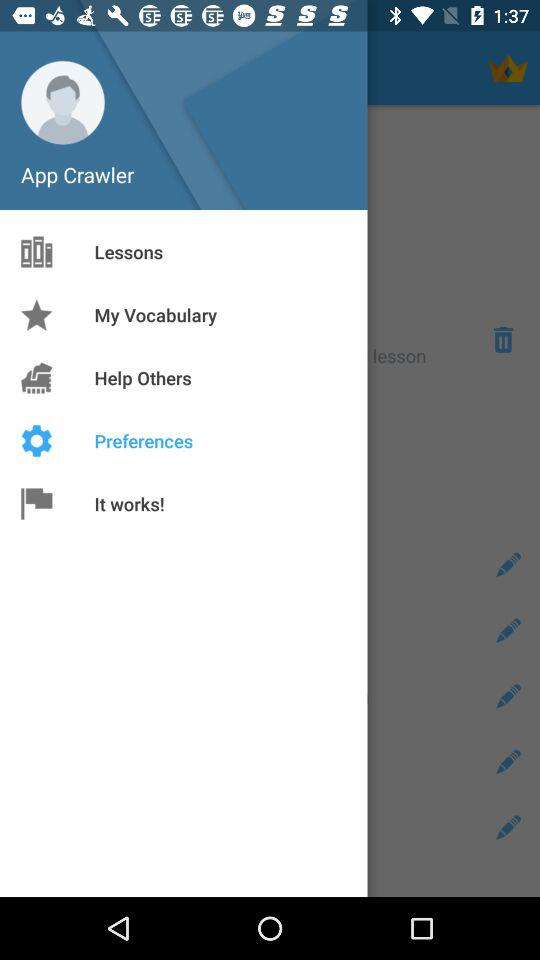What option has been selected? The selected option is "Preferences". 